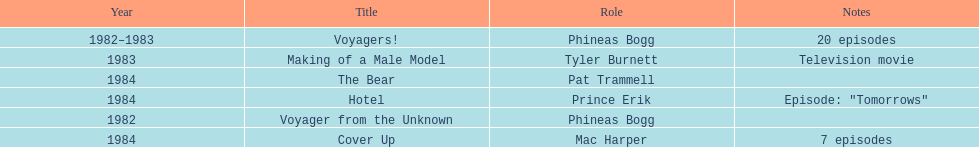How many titles on this list don't feature him as phineas bogg? 4. 